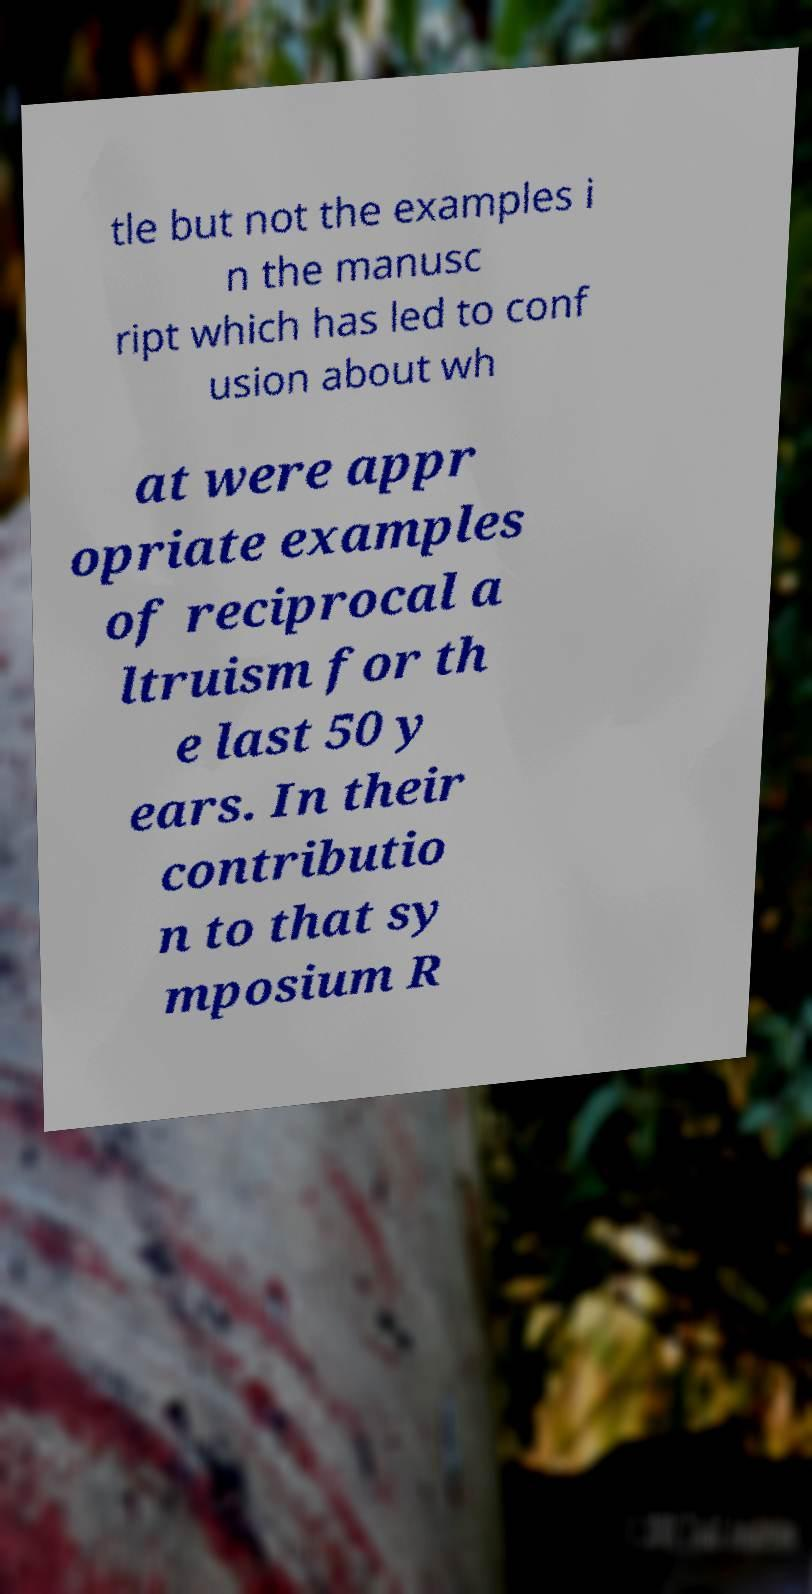Could you assist in decoding the text presented in this image and type it out clearly? tle but not the examples i n the manusc ript which has led to conf usion about wh at were appr opriate examples of reciprocal a ltruism for th e last 50 y ears. In their contributio n to that sy mposium R 